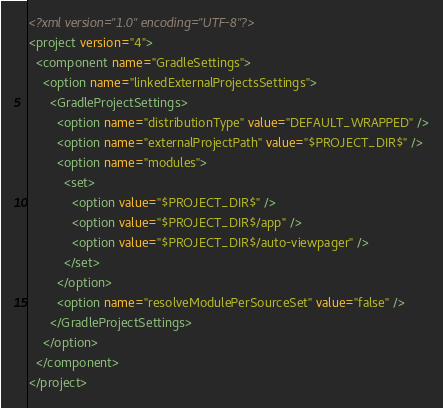Convert code to text. <code><loc_0><loc_0><loc_500><loc_500><_XML_><?xml version="1.0" encoding="UTF-8"?>
<project version="4">
  <component name="GradleSettings">
    <option name="linkedExternalProjectsSettings">
      <GradleProjectSettings>
        <option name="distributionType" value="DEFAULT_WRAPPED" />
        <option name="externalProjectPath" value="$PROJECT_DIR$" />
        <option name="modules">
          <set>
            <option value="$PROJECT_DIR$" />
            <option value="$PROJECT_DIR$/app" />
            <option value="$PROJECT_DIR$/auto-viewpager" />
          </set>
        </option>
        <option name="resolveModulePerSourceSet" value="false" />
      </GradleProjectSettings>
    </option>
  </component>
</project></code> 